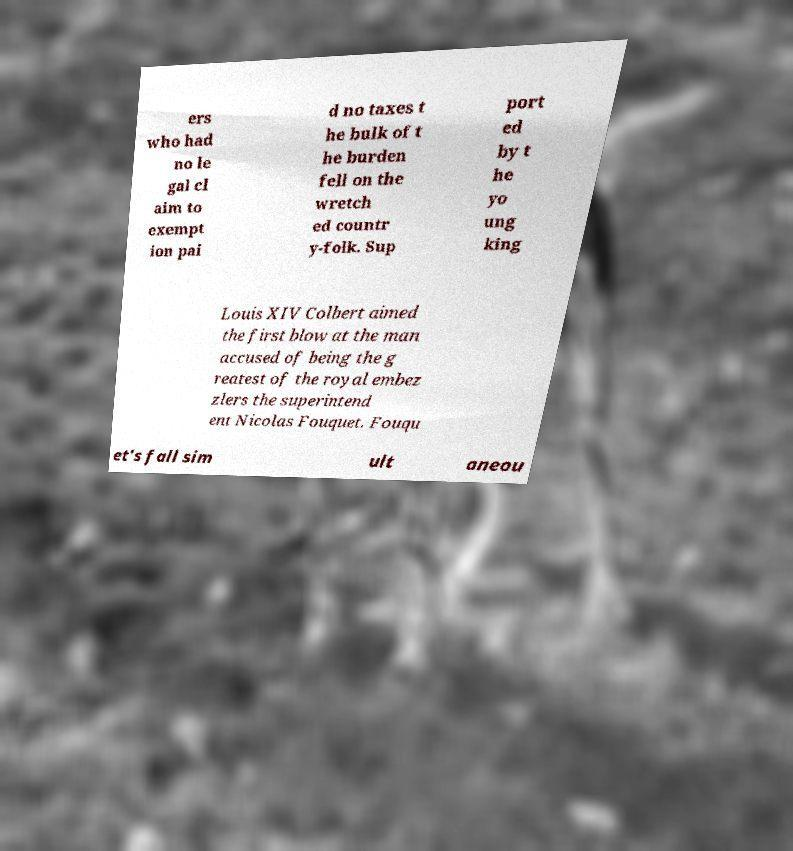Could you assist in decoding the text presented in this image and type it out clearly? ers who had no le gal cl aim to exempt ion pai d no taxes t he bulk of t he burden fell on the wretch ed countr y-folk. Sup port ed by t he yo ung king Louis XIV Colbert aimed the first blow at the man accused of being the g reatest of the royal embez zlers the superintend ent Nicolas Fouquet. Fouqu et's fall sim ult aneou 